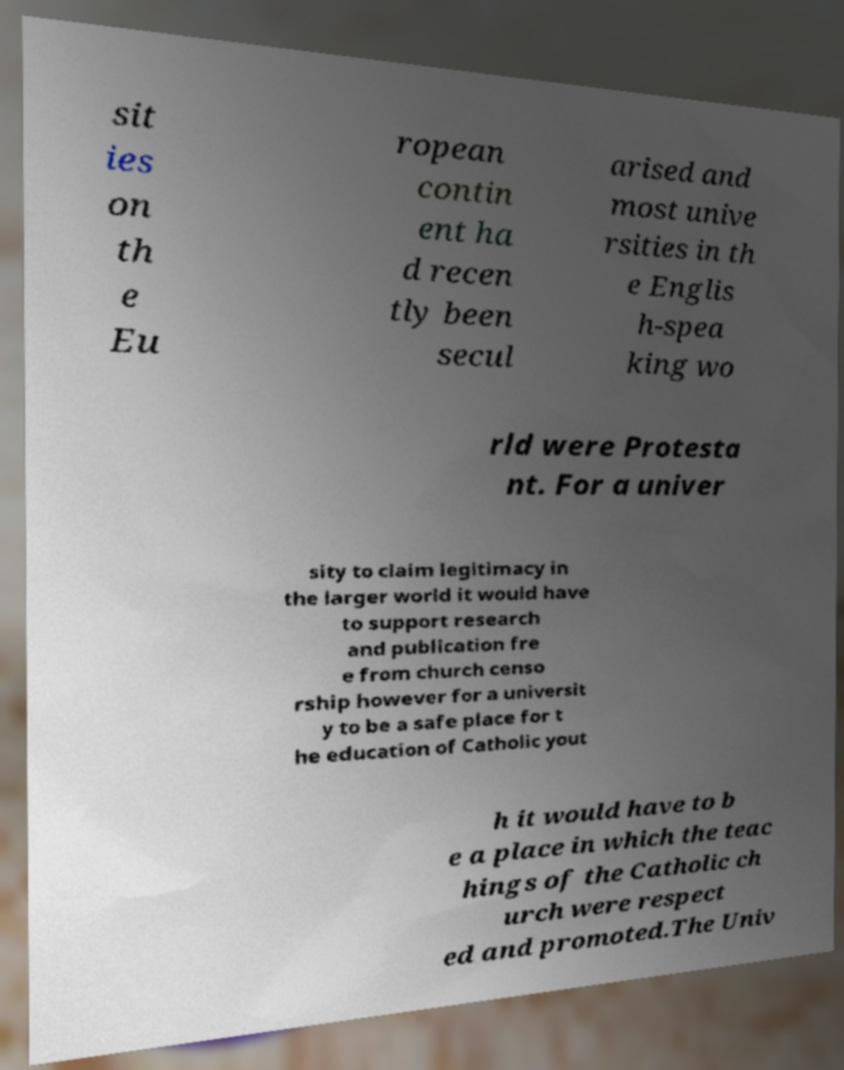Could you assist in decoding the text presented in this image and type it out clearly? sit ies on th e Eu ropean contin ent ha d recen tly been secul arised and most unive rsities in th e Englis h-spea king wo rld were Protesta nt. For a univer sity to claim legitimacy in the larger world it would have to support research and publication fre e from church censo rship however for a universit y to be a safe place for t he education of Catholic yout h it would have to b e a place in which the teac hings of the Catholic ch urch were respect ed and promoted.The Univ 